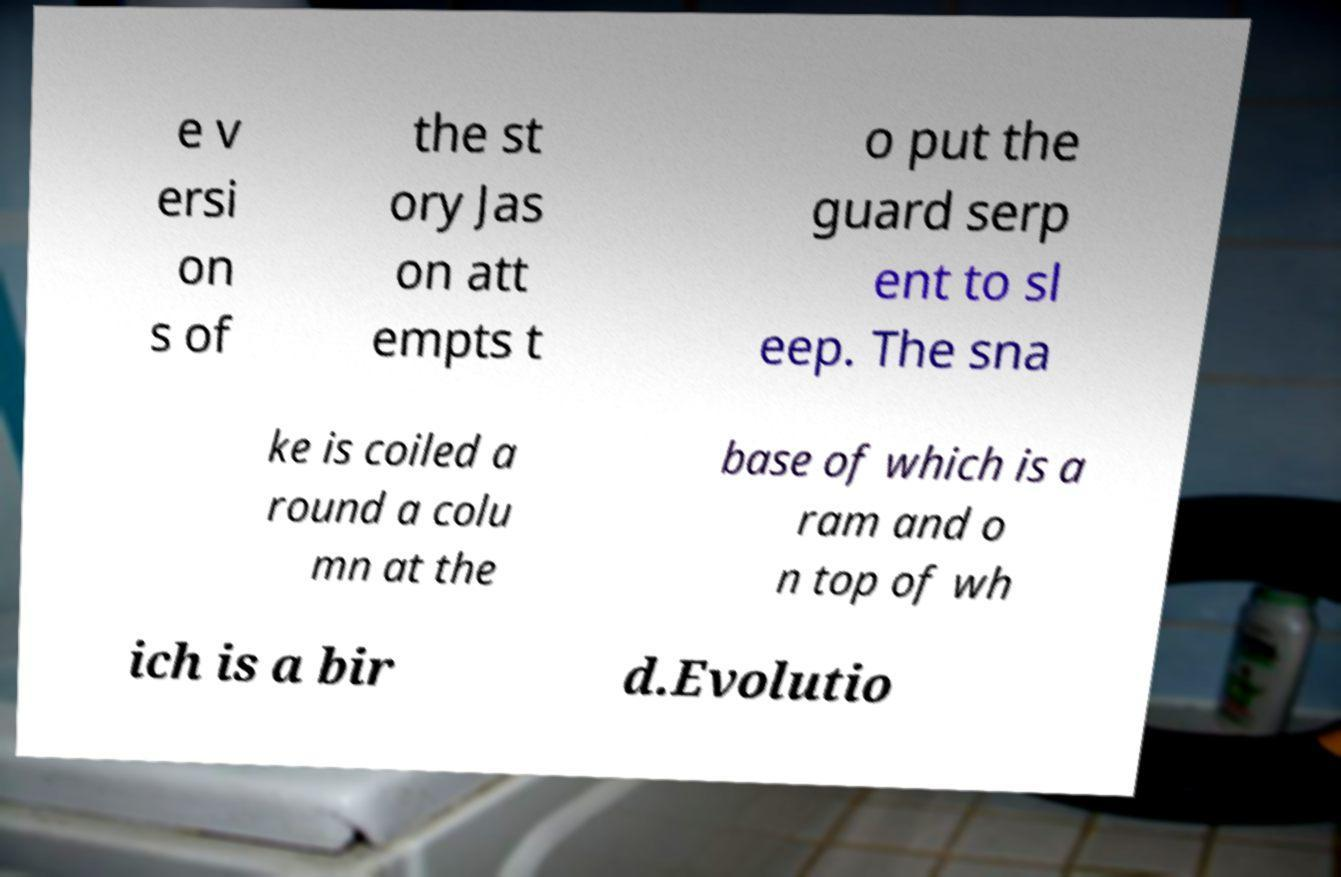Can you accurately transcribe the text from the provided image for me? e v ersi on s of the st ory Jas on att empts t o put the guard serp ent to sl eep. The sna ke is coiled a round a colu mn at the base of which is a ram and o n top of wh ich is a bir d.Evolutio 